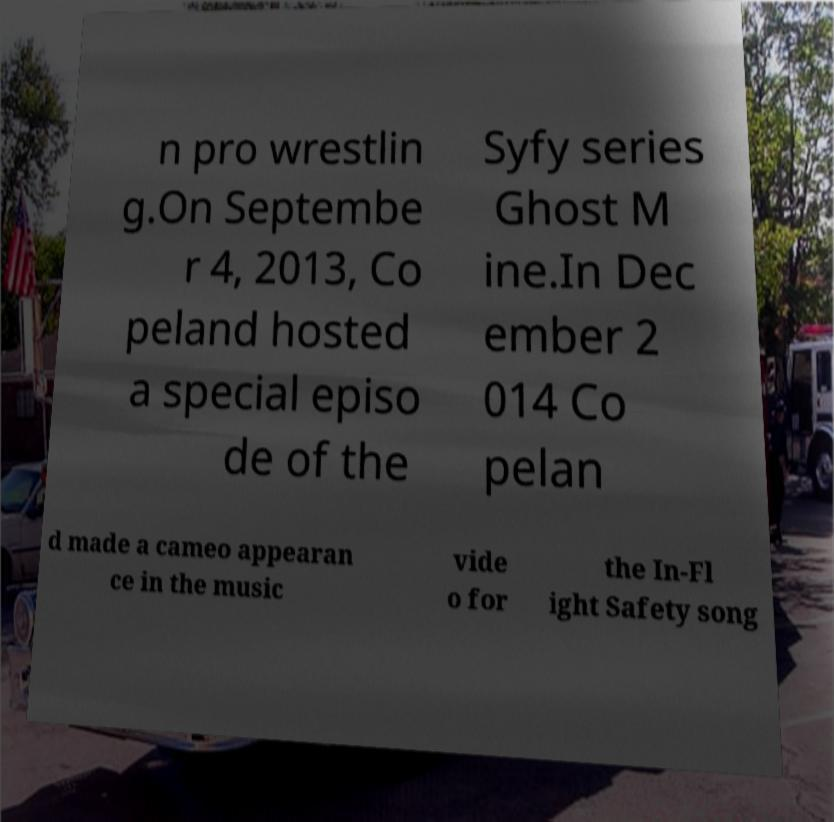Could you assist in decoding the text presented in this image and type it out clearly? n pro wrestlin g.On Septembe r 4, 2013, Co peland hosted a special episo de of the Syfy series Ghost M ine.In Dec ember 2 014 Co pelan d made a cameo appearan ce in the music vide o for the In-Fl ight Safety song 